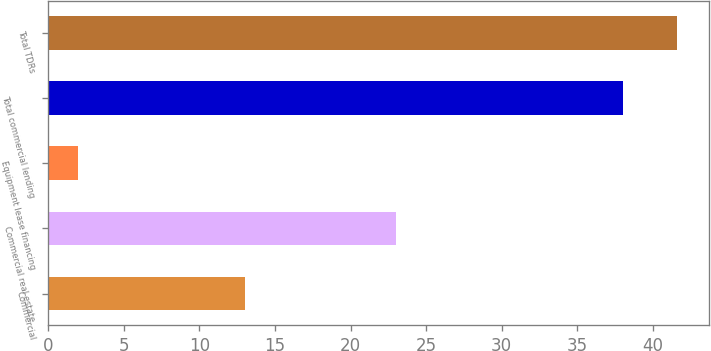<chart> <loc_0><loc_0><loc_500><loc_500><bar_chart><fcel>Commercial<fcel>Commercial real estate<fcel>Equipment lease financing<fcel>Total commercial lending<fcel>Total TDRs<nl><fcel>13<fcel>23<fcel>2<fcel>38<fcel>41.6<nl></chart> 